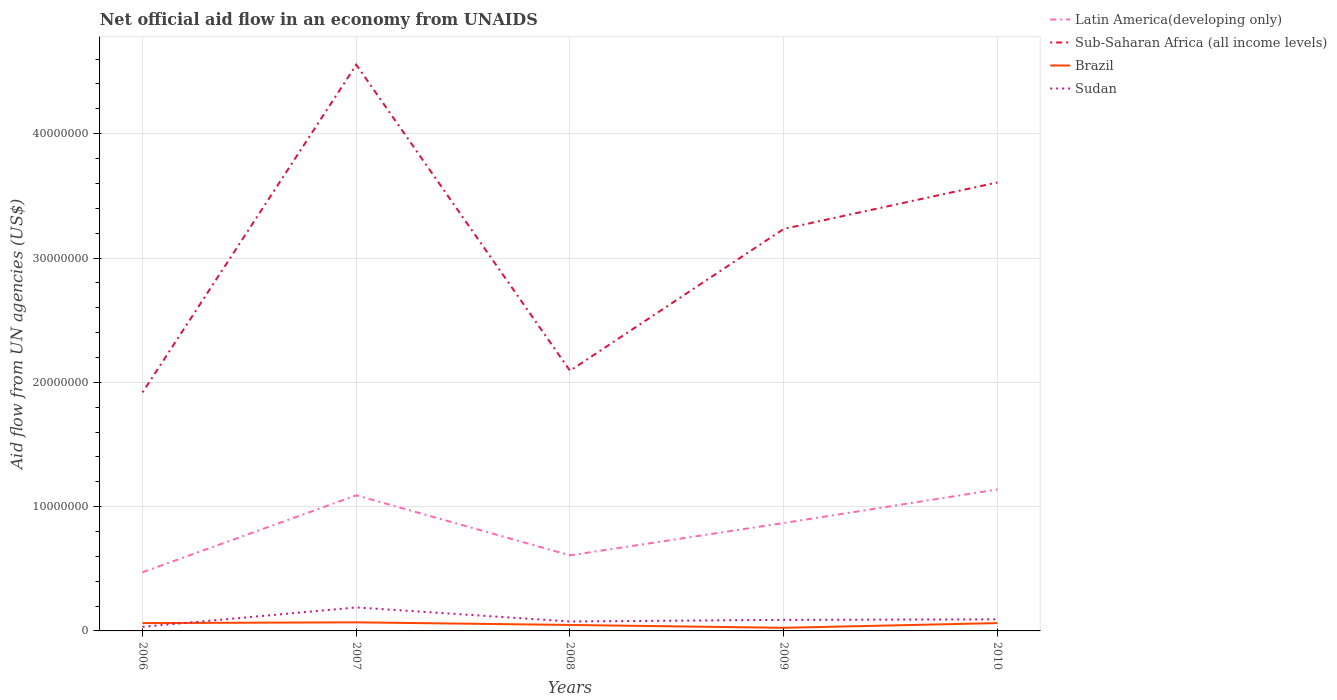Does the line corresponding to Latin America(developing only) intersect with the line corresponding to Sudan?
Offer a terse response. No. Across all years, what is the maximum net official aid flow in Sudan?
Keep it short and to the point. 3.30e+05. In which year was the net official aid flow in Sudan maximum?
Make the answer very short. 2006. What is the total net official aid flow in Sudan in the graph?
Offer a terse response. -6.00e+05. What is the difference between the highest and the second highest net official aid flow in Brazil?
Offer a very short reply. 4.40e+05. What is the difference between the highest and the lowest net official aid flow in Latin America(developing only)?
Your answer should be very brief. 3. Is the net official aid flow in Sudan strictly greater than the net official aid flow in Sub-Saharan Africa (all income levels) over the years?
Offer a terse response. Yes. How many years are there in the graph?
Ensure brevity in your answer.  5. Are the values on the major ticks of Y-axis written in scientific E-notation?
Keep it short and to the point. No. Where does the legend appear in the graph?
Your response must be concise. Top right. How are the legend labels stacked?
Ensure brevity in your answer.  Vertical. What is the title of the graph?
Keep it short and to the point. Net official aid flow in an economy from UNAIDS. What is the label or title of the X-axis?
Your answer should be compact. Years. What is the label or title of the Y-axis?
Your answer should be compact. Aid flow from UN agencies (US$). What is the Aid flow from UN agencies (US$) in Latin America(developing only) in 2006?
Offer a very short reply. 4.72e+06. What is the Aid flow from UN agencies (US$) in Sub-Saharan Africa (all income levels) in 2006?
Provide a short and direct response. 1.92e+07. What is the Aid flow from UN agencies (US$) of Brazil in 2006?
Offer a terse response. 6.30e+05. What is the Aid flow from UN agencies (US$) in Latin America(developing only) in 2007?
Keep it short and to the point. 1.09e+07. What is the Aid flow from UN agencies (US$) of Sub-Saharan Africa (all income levels) in 2007?
Provide a succinct answer. 4.56e+07. What is the Aid flow from UN agencies (US$) in Brazil in 2007?
Offer a terse response. 6.90e+05. What is the Aid flow from UN agencies (US$) in Sudan in 2007?
Ensure brevity in your answer.  1.89e+06. What is the Aid flow from UN agencies (US$) of Latin America(developing only) in 2008?
Make the answer very short. 6.08e+06. What is the Aid flow from UN agencies (US$) in Sub-Saharan Africa (all income levels) in 2008?
Your answer should be very brief. 2.09e+07. What is the Aid flow from UN agencies (US$) of Sudan in 2008?
Your answer should be compact. 7.60e+05. What is the Aid flow from UN agencies (US$) in Latin America(developing only) in 2009?
Make the answer very short. 8.68e+06. What is the Aid flow from UN agencies (US$) in Sub-Saharan Africa (all income levels) in 2009?
Offer a terse response. 3.23e+07. What is the Aid flow from UN agencies (US$) in Brazil in 2009?
Offer a terse response. 2.50e+05. What is the Aid flow from UN agencies (US$) in Sudan in 2009?
Make the answer very short. 8.90e+05. What is the Aid flow from UN agencies (US$) in Latin America(developing only) in 2010?
Your answer should be compact. 1.14e+07. What is the Aid flow from UN agencies (US$) of Sub-Saharan Africa (all income levels) in 2010?
Your answer should be compact. 3.61e+07. What is the Aid flow from UN agencies (US$) in Brazil in 2010?
Your answer should be very brief. 6.30e+05. What is the Aid flow from UN agencies (US$) of Sudan in 2010?
Your response must be concise. 9.30e+05. Across all years, what is the maximum Aid flow from UN agencies (US$) of Latin America(developing only)?
Provide a short and direct response. 1.14e+07. Across all years, what is the maximum Aid flow from UN agencies (US$) of Sub-Saharan Africa (all income levels)?
Offer a terse response. 4.56e+07. Across all years, what is the maximum Aid flow from UN agencies (US$) in Brazil?
Provide a succinct answer. 6.90e+05. Across all years, what is the maximum Aid flow from UN agencies (US$) of Sudan?
Keep it short and to the point. 1.89e+06. Across all years, what is the minimum Aid flow from UN agencies (US$) in Latin America(developing only)?
Offer a terse response. 4.72e+06. Across all years, what is the minimum Aid flow from UN agencies (US$) in Sub-Saharan Africa (all income levels)?
Ensure brevity in your answer.  1.92e+07. Across all years, what is the minimum Aid flow from UN agencies (US$) of Sudan?
Give a very brief answer. 3.30e+05. What is the total Aid flow from UN agencies (US$) of Latin America(developing only) in the graph?
Provide a short and direct response. 4.18e+07. What is the total Aid flow from UN agencies (US$) in Sub-Saharan Africa (all income levels) in the graph?
Offer a very short reply. 1.54e+08. What is the total Aid flow from UN agencies (US$) of Brazil in the graph?
Make the answer very short. 2.68e+06. What is the total Aid flow from UN agencies (US$) of Sudan in the graph?
Ensure brevity in your answer.  4.80e+06. What is the difference between the Aid flow from UN agencies (US$) in Latin America(developing only) in 2006 and that in 2007?
Provide a succinct answer. -6.19e+06. What is the difference between the Aid flow from UN agencies (US$) in Sub-Saharan Africa (all income levels) in 2006 and that in 2007?
Offer a terse response. -2.64e+07. What is the difference between the Aid flow from UN agencies (US$) of Sudan in 2006 and that in 2007?
Provide a succinct answer. -1.56e+06. What is the difference between the Aid flow from UN agencies (US$) of Latin America(developing only) in 2006 and that in 2008?
Give a very brief answer. -1.36e+06. What is the difference between the Aid flow from UN agencies (US$) in Sub-Saharan Africa (all income levels) in 2006 and that in 2008?
Make the answer very short. -1.74e+06. What is the difference between the Aid flow from UN agencies (US$) in Brazil in 2006 and that in 2008?
Ensure brevity in your answer.  1.50e+05. What is the difference between the Aid flow from UN agencies (US$) of Sudan in 2006 and that in 2008?
Your response must be concise. -4.30e+05. What is the difference between the Aid flow from UN agencies (US$) in Latin America(developing only) in 2006 and that in 2009?
Your answer should be very brief. -3.96e+06. What is the difference between the Aid flow from UN agencies (US$) of Sub-Saharan Africa (all income levels) in 2006 and that in 2009?
Offer a terse response. -1.32e+07. What is the difference between the Aid flow from UN agencies (US$) of Sudan in 2006 and that in 2009?
Provide a short and direct response. -5.60e+05. What is the difference between the Aid flow from UN agencies (US$) in Latin America(developing only) in 2006 and that in 2010?
Your answer should be compact. -6.66e+06. What is the difference between the Aid flow from UN agencies (US$) in Sub-Saharan Africa (all income levels) in 2006 and that in 2010?
Keep it short and to the point. -1.69e+07. What is the difference between the Aid flow from UN agencies (US$) of Sudan in 2006 and that in 2010?
Make the answer very short. -6.00e+05. What is the difference between the Aid flow from UN agencies (US$) of Latin America(developing only) in 2007 and that in 2008?
Offer a very short reply. 4.83e+06. What is the difference between the Aid flow from UN agencies (US$) of Sub-Saharan Africa (all income levels) in 2007 and that in 2008?
Your answer should be compact. 2.46e+07. What is the difference between the Aid flow from UN agencies (US$) of Sudan in 2007 and that in 2008?
Offer a very short reply. 1.13e+06. What is the difference between the Aid flow from UN agencies (US$) in Latin America(developing only) in 2007 and that in 2009?
Your answer should be very brief. 2.23e+06. What is the difference between the Aid flow from UN agencies (US$) in Sub-Saharan Africa (all income levels) in 2007 and that in 2009?
Your answer should be very brief. 1.32e+07. What is the difference between the Aid flow from UN agencies (US$) of Sudan in 2007 and that in 2009?
Make the answer very short. 1.00e+06. What is the difference between the Aid flow from UN agencies (US$) in Latin America(developing only) in 2007 and that in 2010?
Ensure brevity in your answer.  -4.70e+05. What is the difference between the Aid flow from UN agencies (US$) of Sub-Saharan Africa (all income levels) in 2007 and that in 2010?
Offer a very short reply. 9.47e+06. What is the difference between the Aid flow from UN agencies (US$) of Sudan in 2007 and that in 2010?
Make the answer very short. 9.60e+05. What is the difference between the Aid flow from UN agencies (US$) in Latin America(developing only) in 2008 and that in 2009?
Offer a very short reply. -2.60e+06. What is the difference between the Aid flow from UN agencies (US$) in Sub-Saharan Africa (all income levels) in 2008 and that in 2009?
Your answer should be compact. -1.14e+07. What is the difference between the Aid flow from UN agencies (US$) in Latin America(developing only) in 2008 and that in 2010?
Your answer should be very brief. -5.30e+06. What is the difference between the Aid flow from UN agencies (US$) of Sub-Saharan Africa (all income levels) in 2008 and that in 2010?
Provide a short and direct response. -1.52e+07. What is the difference between the Aid flow from UN agencies (US$) of Brazil in 2008 and that in 2010?
Your answer should be compact. -1.50e+05. What is the difference between the Aid flow from UN agencies (US$) in Latin America(developing only) in 2009 and that in 2010?
Your response must be concise. -2.70e+06. What is the difference between the Aid flow from UN agencies (US$) in Sub-Saharan Africa (all income levels) in 2009 and that in 2010?
Offer a very short reply. -3.74e+06. What is the difference between the Aid flow from UN agencies (US$) in Brazil in 2009 and that in 2010?
Your response must be concise. -3.80e+05. What is the difference between the Aid flow from UN agencies (US$) in Latin America(developing only) in 2006 and the Aid flow from UN agencies (US$) in Sub-Saharan Africa (all income levels) in 2007?
Ensure brevity in your answer.  -4.08e+07. What is the difference between the Aid flow from UN agencies (US$) in Latin America(developing only) in 2006 and the Aid flow from UN agencies (US$) in Brazil in 2007?
Ensure brevity in your answer.  4.03e+06. What is the difference between the Aid flow from UN agencies (US$) in Latin America(developing only) in 2006 and the Aid flow from UN agencies (US$) in Sudan in 2007?
Offer a very short reply. 2.83e+06. What is the difference between the Aid flow from UN agencies (US$) of Sub-Saharan Africa (all income levels) in 2006 and the Aid flow from UN agencies (US$) of Brazil in 2007?
Your answer should be compact. 1.85e+07. What is the difference between the Aid flow from UN agencies (US$) of Sub-Saharan Africa (all income levels) in 2006 and the Aid flow from UN agencies (US$) of Sudan in 2007?
Your answer should be compact. 1.73e+07. What is the difference between the Aid flow from UN agencies (US$) in Brazil in 2006 and the Aid flow from UN agencies (US$) in Sudan in 2007?
Your answer should be very brief. -1.26e+06. What is the difference between the Aid flow from UN agencies (US$) of Latin America(developing only) in 2006 and the Aid flow from UN agencies (US$) of Sub-Saharan Africa (all income levels) in 2008?
Your response must be concise. -1.62e+07. What is the difference between the Aid flow from UN agencies (US$) of Latin America(developing only) in 2006 and the Aid flow from UN agencies (US$) of Brazil in 2008?
Your response must be concise. 4.24e+06. What is the difference between the Aid flow from UN agencies (US$) of Latin America(developing only) in 2006 and the Aid flow from UN agencies (US$) of Sudan in 2008?
Your answer should be compact. 3.96e+06. What is the difference between the Aid flow from UN agencies (US$) of Sub-Saharan Africa (all income levels) in 2006 and the Aid flow from UN agencies (US$) of Brazil in 2008?
Provide a succinct answer. 1.87e+07. What is the difference between the Aid flow from UN agencies (US$) in Sub-Saharan Africa (all income levels) in 2006 and the Aid flow from UN agencies (US$) in Sudan in 2008?
Your answer should be compact. 1.84e+07. What is the difference between the Aid flow from UN agencies (US$) in Brazil in 2006 and the Aid flow from UN agencies (US$) in Sudan in 2008?
Offer a very short reply. -1.30e+05. What is the difference between the Aid flow from UN agencies (US$) in Latin America(developing only) in 2006 and the Aid flow from UN agencies (US$) in Sub-Saharan Africa (all income levels) in 2009?
Your answer should be compact. -2.76e+07. What is the difference between the Aid flow from UN agencies (US$) in Latin America(developing only) in 2006 and the Aid flow from UN agencies (US$) in Brazil in 2009?
Your response must be concise. 4.47e+06. What is the difference between the Aid flow from UN agencies (US$) in Latin America(developing only) in 2006 and the Aid flow from UN agencies (US$) in Sudan in 2009?
Your answer should be compact. 3.83e+06. What is the difference between the Aid flow from UN agencies (US$) of Sub-Saharan Africa (all income levels) in 2006 and the Aid flow from UN agencies (US$) of Brazil in 2009?
Your answer should be compact. 1.89e+07. What is the difference between the Aid flow from UN agencies (US$) in Sub-Saharan Africa (all income levels) in 2006 and the Aid flow from UN agencies (US$) in Sudan in 2009?
Keep it short and to the point. 1.83e+07. What is the difference between the Aid flow from UN agencies (US$) in Brazil in 2006 and the Aid flow from UN agencies (US$) in Sudan in 2009?
Provide a succinct answer. -2.60e+05. What is the difference between the Aid flow from UN agencies (US$) of Latin America(developing only) in 2006 and the Aid flow from UN agencies (US$) of Sub-Saharan Africa (all income levels) in 2010?
Offer a terse response. -3.14e+07. What is the difference between the Aid flow from UN agencies (US$) of Latin America(developing only) in 2006 and the Aid flow from UN agencies (US$) of Brazil in 2010?
Ensure brevity in your answer.  4.09e+06. What is the difference between the Aid flow from UN agencies (US$) of Latin America(developing only) in 2006 and the Aid flow from UN agencies (US$) of Sudan in 2010?
Offer a terse response. 3.79e+06. What is the difference between the Aid flow from UN agencies (US$) of Sub-Saharan Africa (all income levels) in 2006 and the Aid flow from UN agencies (US$) of Brazil in 2010?
Keep it short and to the point. 1.86e+07. What is the difference between the Aid flow from UN agencies (US$) of Sub-Saharan Africa (all income levels) in 2006 and the Aid flow from UN agencies (US$) of Sudan in 2010?
Your answer should be compact. 1.83e+07. What is the difference between the Aid flow from UN agencies (US$) of Latin America(developing only) in 2007 and the Aid flow from UN agencies (US$) of Sub-Saharan Africa (all income levels) in 2008?
Keep it short and to the point. -1.00e+07. What is the difference between the Aid flow from UN agencies (US$) of Latin America(developing only) in 2007 and the Aid flow from UN agencies (US$) of Brazil in 2008?
Ensure brevity in your answer.  1.04e+07. What is the difference between the Aid flow from UN agencies (US$) in Latin America(developing only) in 2007 and the Aid flow from UN agencies (US$) in Sudan in 2008?
Ensure brevity in your answer.  1.02e+07. What is the difference between the Aid flow from UN agencies (US$) of Sub-Saharan Africa (all income levels) in 2007 and the Aid flow from UN agencies (US$) of Brazil in 2008?
Your answer should be very brief. 4.51e+07. What is the difference between the Aid flow from UN agencies (US$) in Sub-Saharan Africa (all income levels) in 2007 and the Aid flow from UN agencies (US$) in Sudan in 2008?
Provide a succinct answer. 4.48e+07. What is the difference between the Aid flow from UN agencies (US$) in Latin America(developing only) in 2007 and the Aid flow from UN agencies (US$) in Sub-Saharan Africa (all income levels) in 2009?
Provide a succinct answer. -2.14e+07. What is the difference between the Aid flow from UN agencies (US$) of Latin America(developing only) in 2007 and the Aid flow from UN agencies (US$) of Brazil in 2009?
Offer a terse response. 1.07e+07. What is the difference between the Aid flow from UN agencies (US$) in Latin America(developing only) in 2007 and the Aid flow from UN agencies (US$) in Sudan in 2009?
Make the answer very short. 1.00e+07. What is the difference between the Aid flow from UN agencies (US$) in Sub-Saharan Africa (all income levels) in 2007 and the Aid flow from UN agencies (US$) in Brazil in 2009?
Your answer should be compact. 4.53e+07. What is the difference between the Aid flow from UN agencies (US$) of Sub-Saharan Africa (all income levels) in 2007 and the Aid flow from UN agencies (US$) of Sudan in 2009?
Offer a very short reply. 4.47e+07. What is the difference between the Aid flow from UN agencies (US$) of Latin America(developing only) in 2007 and the Aid flow from UN agencies (US$) of Sub-Saharan Africa (all income levels) in 2010?
Provide a short and direct response. -2.52e+07. What is the difference between the Aid flow from UN agencies (US$) of Latin America(developing only) in 2007 and the Aid flow from UN agencies (US$) of Brazil in 2010?
Provide a succinct answer. 1.03e+07. What is the difference between the Aid flow from UN agencies (US$) of Latin America(developing only) in 2007 and the Aid flow from UN agencies (US$) of Sudan in 2010?
Keep it short and to the point. 9.98e+06. What is the difference between the Aid flow from UN agencies (US$) of Sub-Saharan Africa (all income levels) in 2007 and the Aid flow from UN agencies (US$) of Brazil in 2010?
Offer a terse response. 4.49e+07. What is the difference between the Aid flow from UN agencies (US$) of Sub-Saharan Africa (all income levels) in 2007 and the Aid flow from UN agencies (US$) of Sudan in 2010?
Your answer should be compact. 4.46e+07. What is the difference between the Aid flow from UN agencies (US$) in Latin America(developing only) in 2008 and the Aid flow from UN agencies (US$) in Sub-Saharan Africa (all income levels) in 2009?
Provide a short and direct response. -2.63e+07. What is the difference between the Aid flow from UN agencies (US$) in Latin America(developing only) in 2008 and the Aid flow from UN agencies (US$) in Brazil in 2009?
Your response must be concise. 5.83e+06. What is the difference between the Aid flow from UN agencies (US$) of Latin America(developing only) in 2008 and the Aid flow from UN agencies (US$) of Sudan in 2009?
Offer a terse response. 5.19e+06. What is the difference between the Aid flow from UN agencies (US$) of Sub-Saharan Africa (all income levels) in 2008 and the Aid flow from UN agencies (US$) of Brazil in 2009?
Keep it short and to the point. 2.07e+07. What is the difference between the Aid flow from UN agencies (US$) of Sub-Saharan Africa (all income levels) in 2008 and the Aid flow from UN agencies (US$) of Sudan in 2009?
Offer a terse response. 2.00e+07. What is the difference between the Aid flow from UN agencies (US$) of Brazil in 2008 and the Aid flow from UN agencies (US$) of Sudan in 2009?
Provide a short and direct response. -4.10e+05. What is the difference between the Aid flow from UN agencies (US$) of Latin America(developing only) in 2008 and the Aid flow from UN agencies (US$) of Sub-Saharan Africa (all income levels) in 2010?
Offer a terse response. -3.00e+07. What is the difference between the Aid flow from UN agencies (US$) in Latin America(developing only) in 2008 and the Aid flow from UN agencies (US$) in Brazil in 2010?
Your answer should be compact. 5.45e+06. What is the difference between the Aid flow from UN agencies (US$) of Latin America(developing only) in 2008 and the Aid flow from UN agencies (US$) of Sudan in 2010?
Offer a terse response. 5.15e+06. What is the difference between the Aid flow from UN agencies (US$) in Sub-Saharan Africa (all income levels) in 2008 and the Aid flow from UN agencies (US$) in Brazil in 2010?
Your response must be concise. 2.03e+07. What is the difference between the Aid flow from UN agencies (US$) in Brazil in 2008 and the Aid flow from UN agencies (US$) in Sudan in 2010?
Provide a succinct answer. -4.50e+05. What is the difference between the Aid flow from UN agencies (US$) of Latin America(developing only) in 2009 and the Aid flow from UN agencies (US$) of Sub-Saharan Africa (all income levels) in 2010?
Ensure brevity in your answer.  -2.74e+07. What is the difference between the Aid flow from UN agencies (US$) in Latin America(developing only) in 2009 and the Aid flow from UN agencies (US$) in Brazil in 2010?
Offer a terse response. 8.05e+06. What is the difference between the Aid flow from UN agencies (US$) of Latin America(developing only) in 2009 and the Aid flow from UN agencies (US$) of Sudan in 2010?
Offer a terse response. 7.75e+06. What is the difference between the Aid flow from UN agencies (US$) of Sub-Saharan Africa (all income levels) in 2009 and the Aid flow from UN agencies (US$) of Brazil in 2010?
Your response must be concise. 3.17e+07. What is the difference between the Aid flow from UN agencies (US$) in Sub-Saharan Africa (all income levels) in 2009 and the Aid flow from UN agencies (US$) in Sudan in 2010?
Provide a succinct answer. 3.14e+07. What is the difference between the Aid flow from UN agencies (US$) of Brazil in 2009 and the Aid flow from UN agencies (US$) of Sudan in 2010?
Offer a terse response. -6.80e+05. What is the average Aid flow from UN agencies (US$) of Latin America(developing only) per year?
Make the answer very short. 8.35e+06. What is the average Aid flow from UN agencies (US$) in Sub-Saharan Africa (all income levels) per year?
Give a very brief answer. 3.08e+07. What is the average Aid flow from UN agencies (US$) of Brazil per year?
Ensure brevity in your answer.  5.36e+05. What is the average Aid flow from UN agencies (US$) in Sudan per year?
Provide a succinct answer. 9.60e+05. In the year 2006, what is the difference between the Aid flow from UN agencies (US$) of Latin America(developing only) and Aid flow from UN agencies (US$) of Sub-Saharan Africa (all income levels)?
Your answer should be very brief. -1.45e+07. In the year 2006, what is the difference between the Aid flow from UN agencies (US$) in Latin America(developing only) and Aid flow from UN agencies (US$) in Brazil?
Keep it short and to the point. 4.09e+06. In the year 2006, what is the difference between the Aid flow from UN agencies (US$) in Latin America(developing only) and Aid flow from UN agencies (US$) in Sudan?
Give a very brief answer. 4.39e+06. In the year 2006, what is the difference between the Aid flow from UN agencies (US$) in Sub-Saharan Africa (all income levels) and Aid flow from UN agencies (US$) in Brazil?
Give a very brief answer. 1.86e+07. In the year 2006, what is the difference between the Aid flow from UN agencies (US$) in Sub-Saharan Africa (all income levels) and Aid flow from UN agencies (US$) in Sudan?
Offer a terse response. 1.89e+07. In the year 2006, what is the difference between the Aid flow from UN agencies (US$) of Brazil and Aid flow from UN agencies (US$) of Sudan?
Provide a succinct answer. 3.00e+05. In the year 2007, what is the difference between the Aid flow from UN agencies (US$) in Latin America(developing only) and Aid flow from UN agencies (US$) in Sub-Saharan Africa (all income levels)?
Keep it short and to the point. -3.46e+07. In the year 2007, what is the difference between the Aid flow from UN agencies (US$) in Latin America(developing only) and Aid flow from UN agencies (US$) in Brazil?
Make the answer very short. 1.02e+07. In the year 2007, what is the difference between the Aid flow from UN agencies (US$) of Latin America(developing only) and Aid flow from UN agencies (US$) of Sudan?
Your answer should be compact. 9.02e+06. In the year 2007, what is the difference between the Aid flow from UN agencies (US$) in Sub-Saharan Africa (all income levels) and Aid flow from UN agencies (US$) in Brazil?
Your answer should be compact. 4.49e+07. In the year 2007, what is the difference between the Aid flow from UN agencies (US$) of Sub-Saharan Africa (all income levels) and Aid flow from UN agencies (US$) of Sudan?
Keep it short and to the point. 4.37e+07. In the year 2007, what is the difference between the Aid flow from UN agencies (US$) in Brazil and Aid flow from UN agencies (US$) in Sudan?
Offer a very short reply. -1.20e+06. In the year 2008, what is the difference between the Aid flow from UN agencies (US$) in Latin America(developing only) and Aid flow from UN agencies (US$) in Sub-Saharan Africa (all income levels)?
Your response must be concise. -1.48e+07. In the year 2008, what is the difference between the Aid flow from UN agencies (US$) in Latin America(developing only) and Aid flow from UN agencies (US$) in Brazil?
Offer a very short reply. 5.60e+06. In the year 2008, what is the difference between the Aid flow from UN agencies (US$) in Latin America(developing only) and Aid flow from UN agencies (US$) in Sudan?
Keep it short and to the point. 5.32e+06. In the year 2008, what is the difference between the Aid flow from UN agencies (US$) in Sub-Saharan Africa (all income levels) and Aid flow from UN agencies (US$) in Brazil?
Ensure brevity in your answer.  2.04e+07. In the year 2008, what is the difference between the Aid flow from UN agencies (US$) in Sub-Saharan Africa (all income levels) and Aid flow from UN agencies (US$) in Sudan?
Keep it short and to the point. 2.02e+07. In the year 2008, what is the difference between the Aid flow from UN agencies (US$) in Brazil and Aid flow from UN agencies (US$) in Sudan?
Give a very brief answer. -2.80e+05. In the year 2009, what is the difference between the Aid flow from UN agencies (US$) of Latin America(developing only) and Aid flow from UN agencies (US$) of Sub-Saharan Africa (all income levels)?
Your response must be concise. -2.37e+07. In the year 2009, what is the difference between the Aid flow from UN agencies (US$) in Latin America(developing only) and Aid flow from UN agencies (US$) in Brazil?
Provide a succinct answer. 8.43e+06. In the year 2009, what is the difference between the Aid flow from UN agencies (US$) in Latin America(developing only) and Aid flow from UN agencies (US$) in Sudan?
Your response must be concise. 7.79e+06. In the year 2009, what is the difference between the Aid flow from UN agencies (US$) of Sub-Saharan Africa (all income levels) and Aid flow from UN agencies (US$) of Brazil?
Your response must be concise. 3.21e+07. In the year 2009, what is the difference between the Aid flow from UN agencies (US$) in Sub-Saharan Africa (all income levels) and Aid flow from UN agencies (US$) in Sudan?
Provide a short and direct response. 3.14e+07. In the year 2009, what is the difference between the Aid flow from UN agencies (US$) in Brazil and Aid flow from UN agencies (US$) in Sudan?
Ensure brevity in your answer.  -6.40e+05. In the year 2010, what is the difference between the Aid flow from UN agencies (US$) of Latin America(developing only) and Aid flow from UN agencies (US$) of Sub-Saharan Africa (all income levels)?
Ensure brevity in your answer.  -2.47e+07. In the year 2010, what is the difference between the Aid flow from UN agencies (US$) in Latin America(developing only) and Aid flow from UN agencies (US$) in Brazil?
Your response must be concise. 1.08e+07. In the year 2010, what is the difference between the Aid flow from UN agencies (US$) in Latin America(developing only) and Aid flow from UN agencies (US$) in Sudan?
Offer a terse response. 1.04e+07. In the year 2010, what is the difference between the Aid flow from UN agencies (US$) in Sub-Saharan Africa (all income levels) and Aid flow from UN agencies (US$) in Brazil?
Make the answer very short. 3.54e+07. In the year 2010, what is the difference between the Aid flow from UN agencies (US$) in Sub-Saharan Africa (all income levels) and Aid flow from UN agencies (US$) in Sudan?
Your response must be concise. 3.52e+07. In the year 2010, what is the difference between the Aid flow from UN agencies (US$) of Brazil and Aid flow from UN agencies (US$) of Sudan?
Offer a terse response. -3.00e+05. What is the ratio of the Aid flow from UN agencies (US$) of Latin America(developing only) in 2006 to that in 2007?
Keep it short and to the point. 0.43. What is the ratio of the Aid flow from UN agencies (US$) in Sub-Saharan Africa (all income levels) in 2006 to that in 2007?
Make the answer very short. 0.42. What is the ratio of the Aid flow from UN agencies (US$) of Sudan in 2006 to that in 2007?
Your response must be concise. 0.17. What is the ratio of the Aid flow from UN agencies (US$) of Latin America(developing only) in 2006 to that in 2008?
Give a very brief answer. 0.78. What is the ratio of the Aid flow from UN agencies (US$) of Sub-Saharan Africa (all income levels) in 2006 to that in 2008?
Provide a short and direct response. 0.92. What is the ratio of the Aid flow from UN agencies (US$) of Brazil in 2006 to that in 2008?
Provide a succinct answer. 1.31. What is the ratio of the Aid flow from UN agencies (US$) in Sudan in 2006 to that in 2008?
Your response must be concise. 0.43. What is the ratio of the Aid flow from UN agencies (US$) in Latin America(developing only) in 2006 to that in 2009?
Provide a short and direct response. 0.54. What is the ratio of the Aid flow from UN agencies (US$) of Sub-Saharan Africa (all income levels) in 2006 to that in 2009?
Your response must be concise. 0.59. What is the ratio of the Aid flow from UN agencies (US$) of Brazil in 2006 to that in 2009?
Make the answer very short. 2.52. What is the ratio of the Aid flow from UN agencies (US$) in Sudan in 2006 to that in 2009?
Offer a terse response. 0.37. What is the ratio of the Aid flow from UN agencies (US$) of Latin America(developing only) in 2006 to that in 2010?
Offer a very short reply. 0.41. What is the ratio of the Aid flow from UN agencies (US$) of Sub-Saharan Africa (all income levels) in 2006 to that in 2010?
Your answer should be very brief. 0.53. What is the ratio of the Aid flow from UN agencies (US$) in Sudan in 2006 to that in 2010?
Ensure brevity in your answer.  0.35. What is the ratio of the Aid flow from UN agencies (US$) of Latin America(developing only) in 2007 to that in 2008?
Ensure brevity in your answer.  1.79. What is the ratio of the Aid flow from UN agencies (US$) in Sub-Saharan Africa (all income levels) in 2007 to that in 2008?
Your response must be concise. 2.18. What is the ratio of the Aid flow from UN agencies (US$) in Brazil in 2007 to that in 2008?
Offer a very short reply. 1.44. What is the ratio of the Aid flow from UN agencies (US$) in Sudan in 2007 to that in 2008?
Keep it short and to the point. 2.49. What is the ratio of the Aid flow from UN agencies (US$) in Latin America(developing only) in 2007 to that in 2009?
Offer a very short reply. 1.26. What is the ratio of the Aid flow from UN agencies (US$) of Sub-Saharan Africa (all income levels) in 2007 to that in 2009?
Ensure brevity in your answer.  1.41. What is the ratio of the Aid flow from UN agencies (US$) in Brazil in 2007 to that in 2009?
Your response must be concise. 2.76. What is the ratio of the Aid flow from UN agencies (US$) of Sudan in 2007 to that in 2009?
Offer a very short reply. 2.12. What is the ratio of the Aid flow from UN agencies (US$) of Latin America(developing only) in 2007 to that in 2010?
Offer a terse response. 0.96. What is the ratio of the Aid flow from UN agencies (US$) in Sub-Saharan Africa (all income levels) in 2007 to that in 2010?
Ensure brevity in your answer.  1.26. What is the ratio of the Aid flow from UN agencies (US$) in Brazil in 2007 to that in 2010?
Ensure brevity in your answer.  1.1. What is the ratio of the Aid flow from UN agencies (US$) in Sudan in 2007 to that in 2010?
Keep it short and to the point. 2.03. What is the ratio of the Aid flow from UN agencies (US$) of Latin America(developing only) in 2008 to that in 2009?
Make the answer very short. 0.7. What is the ratio of the Aid flow from UN agencies (US$) of Sub-Saharan Africa (all income levels) in 2008 to that in 2009?
Offer a very short reply. 0.65. What is the ratio of the Aid flow from UN agencies (US$) of Brazil in 2008 to that in 2009?
Your answer should be compact. 1.92. What is the ratio of the Aid flow from UN agencies (US$) in Sudan in 2008 to that in 2009?
Provide a short and direct response. 0.85. What is the ratio of the Aid flow from UN agencies (US$) of Latin America(developing only) in 2008 to that in 2010?
Make the answer very short. 0.53. What is the ratio of the Aid flow from UN agencies (US$) of Sub-Saharan Africa (all income levels) in 2008 to that in 2010?
Provide a short and direct response. 0.58. What is the ratio of the Aid flow from UN agencies (US$) in Brazil in 2008 to that in 2010?
Make the answer very short. 0.76. What is the ratio of the Aid flow from UN agencies (US$) in Sudan in 2008 to that in 2010?
Give a very brief answer. 0.82. What is the ratio of the Aid flow from UN agencies (US$) in Latin America(developing only) in 2009 to that in 2010?
Provide a succinct answer. 0.76. What is the ratio of the Aid flow from UN agencies (US$) of Sub-Saharan Africa (all income levels) in 2009 to that in 2010?
Offer a very short reply. 0.9. What is the ratio of the Aid flow from UN agencies (US$) in Brazil in 2009 to that in 2010?
Provide a succinct answer. 0.4. What is the difference between the highest and the second highest Aid flow from UN agencies (US$) of Sub-Saharan Africa (all income levels)?
Offer a very short reply. 9.47e+06. What is the difference between the highest and the second highest Aid flow from UN agencies (US$) of Sudan?
Provide a short and direct response. 9.60e+05. What is the difference between the highest and the lowest Aid flow from UN agencies (US$) of Latin America(developing only)?
Your answer should be very brief. 6.66e+06. What is the difference between the highest and the lowest Aid flow from UN agencies (US$) of Sub-Saharan Africa (all income levels)?
Provide a succinct answer. 2.64e+07. What is the difference between the highest and the lowest Aid flow from UN agencies (US$) of Sudan?
Provide a succinct answer. 1.56e+06. 